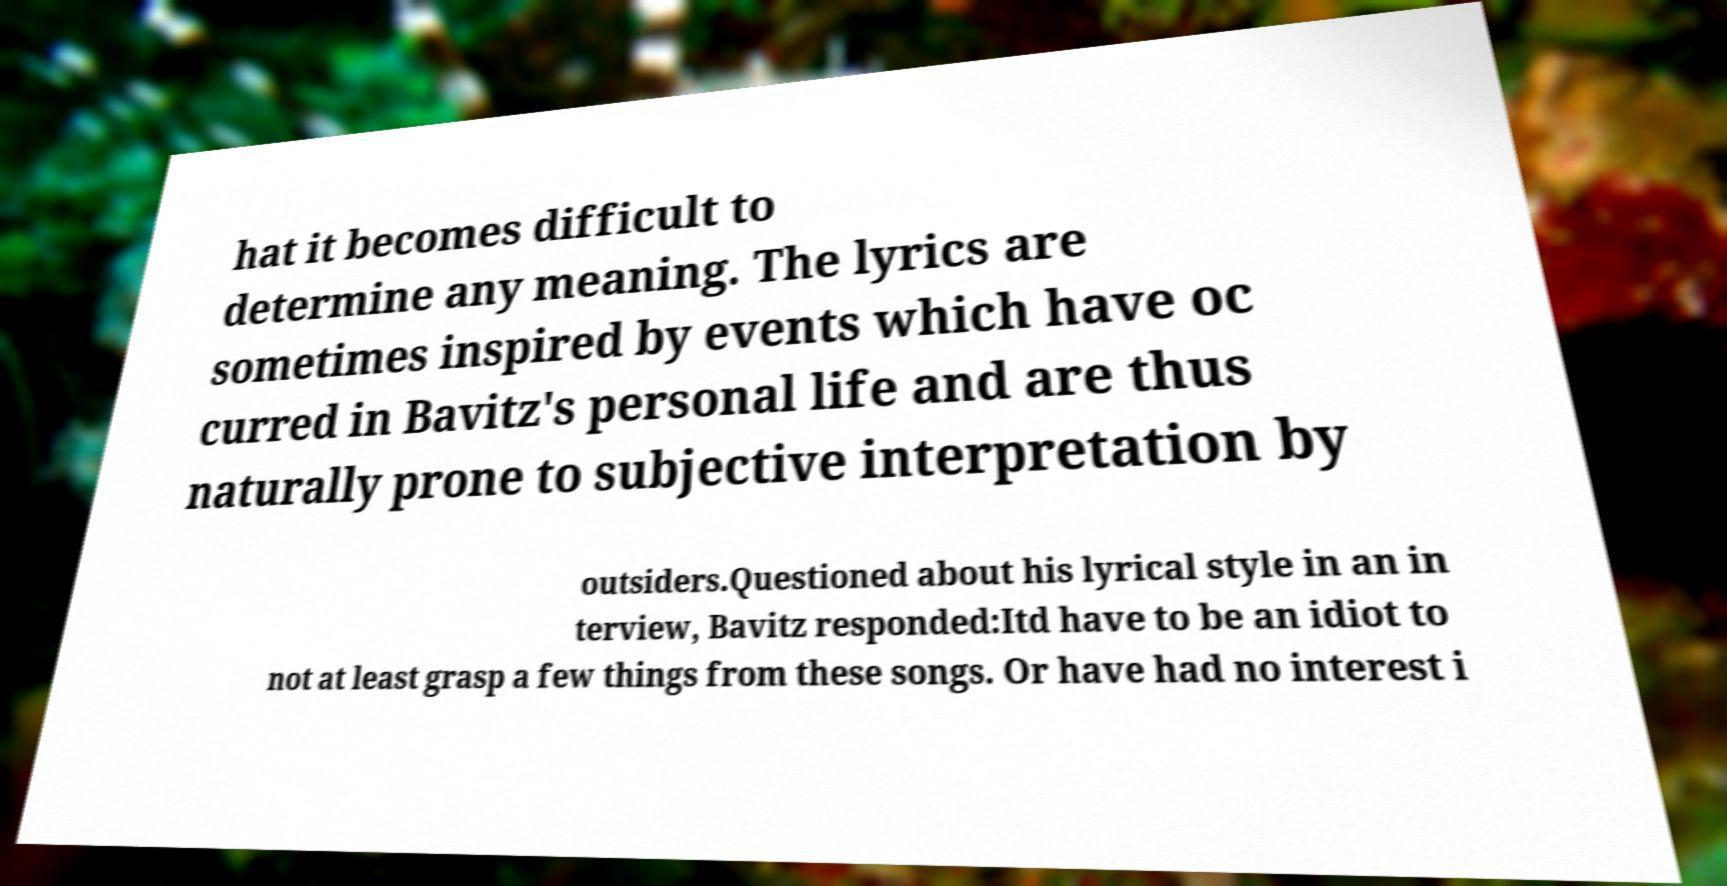What messages or text are displayed in this image? I need them in a readable, typed format. hat it becomes difficult to determine any meaning. The lyrics are sometimes inspired by events which have oc curred in Bavitz's personal life and are thus naturally prone to subjective interpretation by outsiders.Questioned about his lyrical style in an in terview, Bavitz responded:Itd have to be an idiot to not at least grasp a few things from these songs. Or have had no interest i 